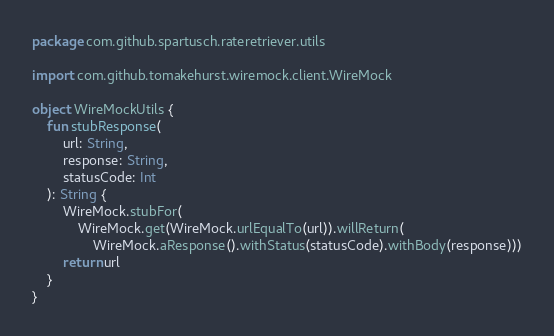Convert code to text. <code><loc_0><loc_0><loc_500><loc_500><_Kotlin_>package com.github.spartusch.rateretriever.utils

import com.github.tomakehurst.wiremock.client.WireMock

object WireMockUtils {
    fun stubResponse(
        url: String,
        response: String,
        statusCode: Int
    ): String {
        WireMock.stubFor(
            WireMock.get(WireMock.urlEqualTo(url)).willReturn(
                WireMock.aResponse().withStatus(statusCode).withBody(response)))
        return url
    }
}
</code> 